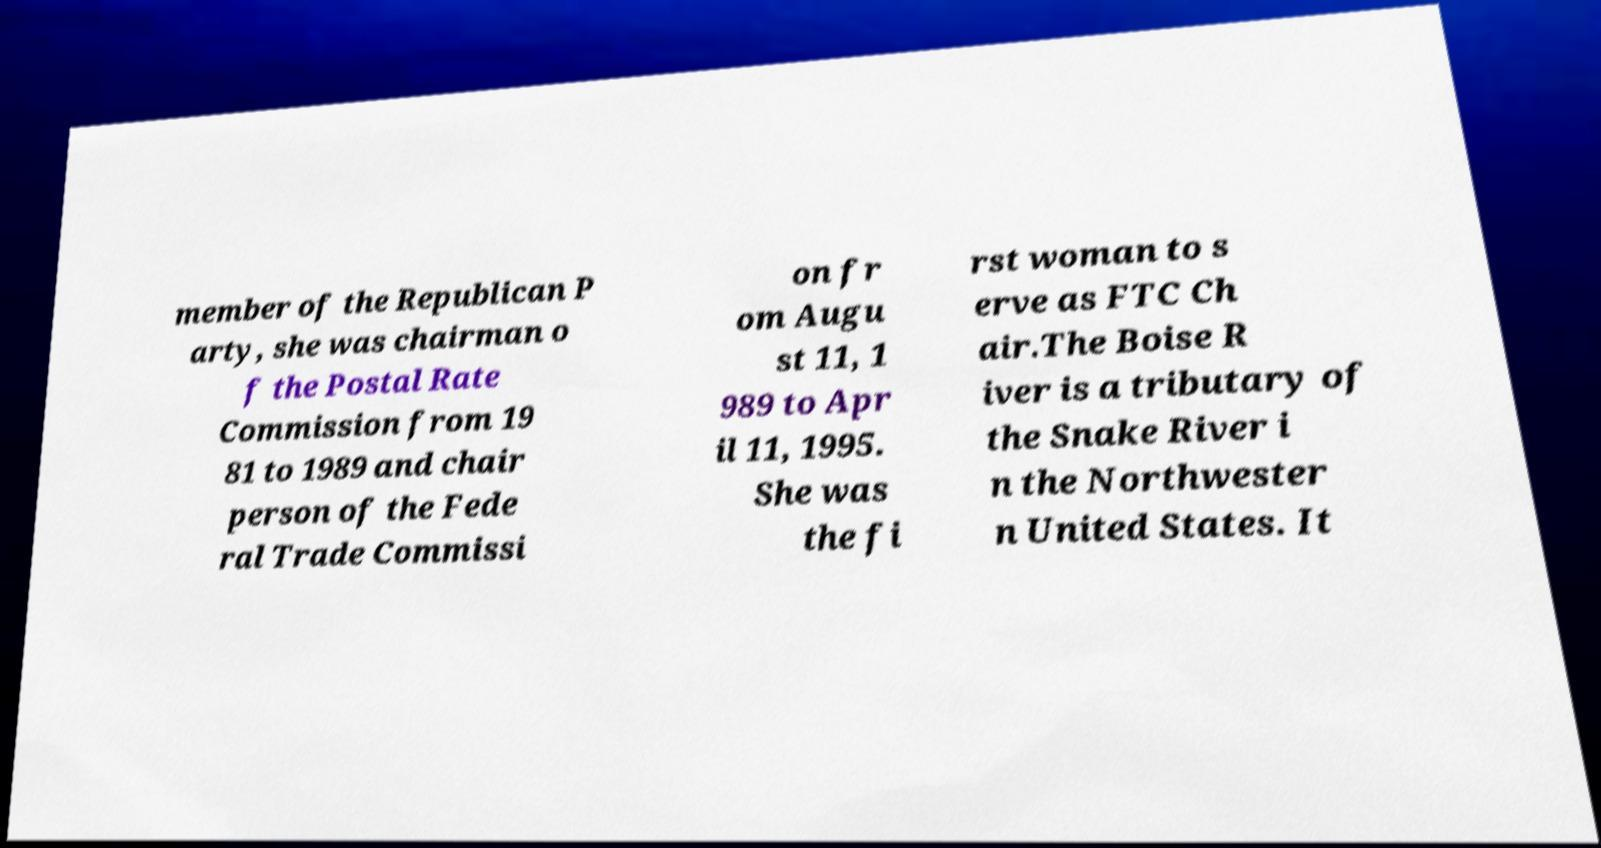Could you extract and type out the text from this image? member of the Republican P arty, she was chairman o f the Postal Rate Commission from 19 81 to 1989 and chair person of the Fede ral Trade Commissi on fr om Augu st 11, 1 989 to Apr il 11, 1995. She was the fi rst woman to s erve as FTC Ch air.The Boise R iver is a tributary of the Snake River i n the Northwester n United States. It 